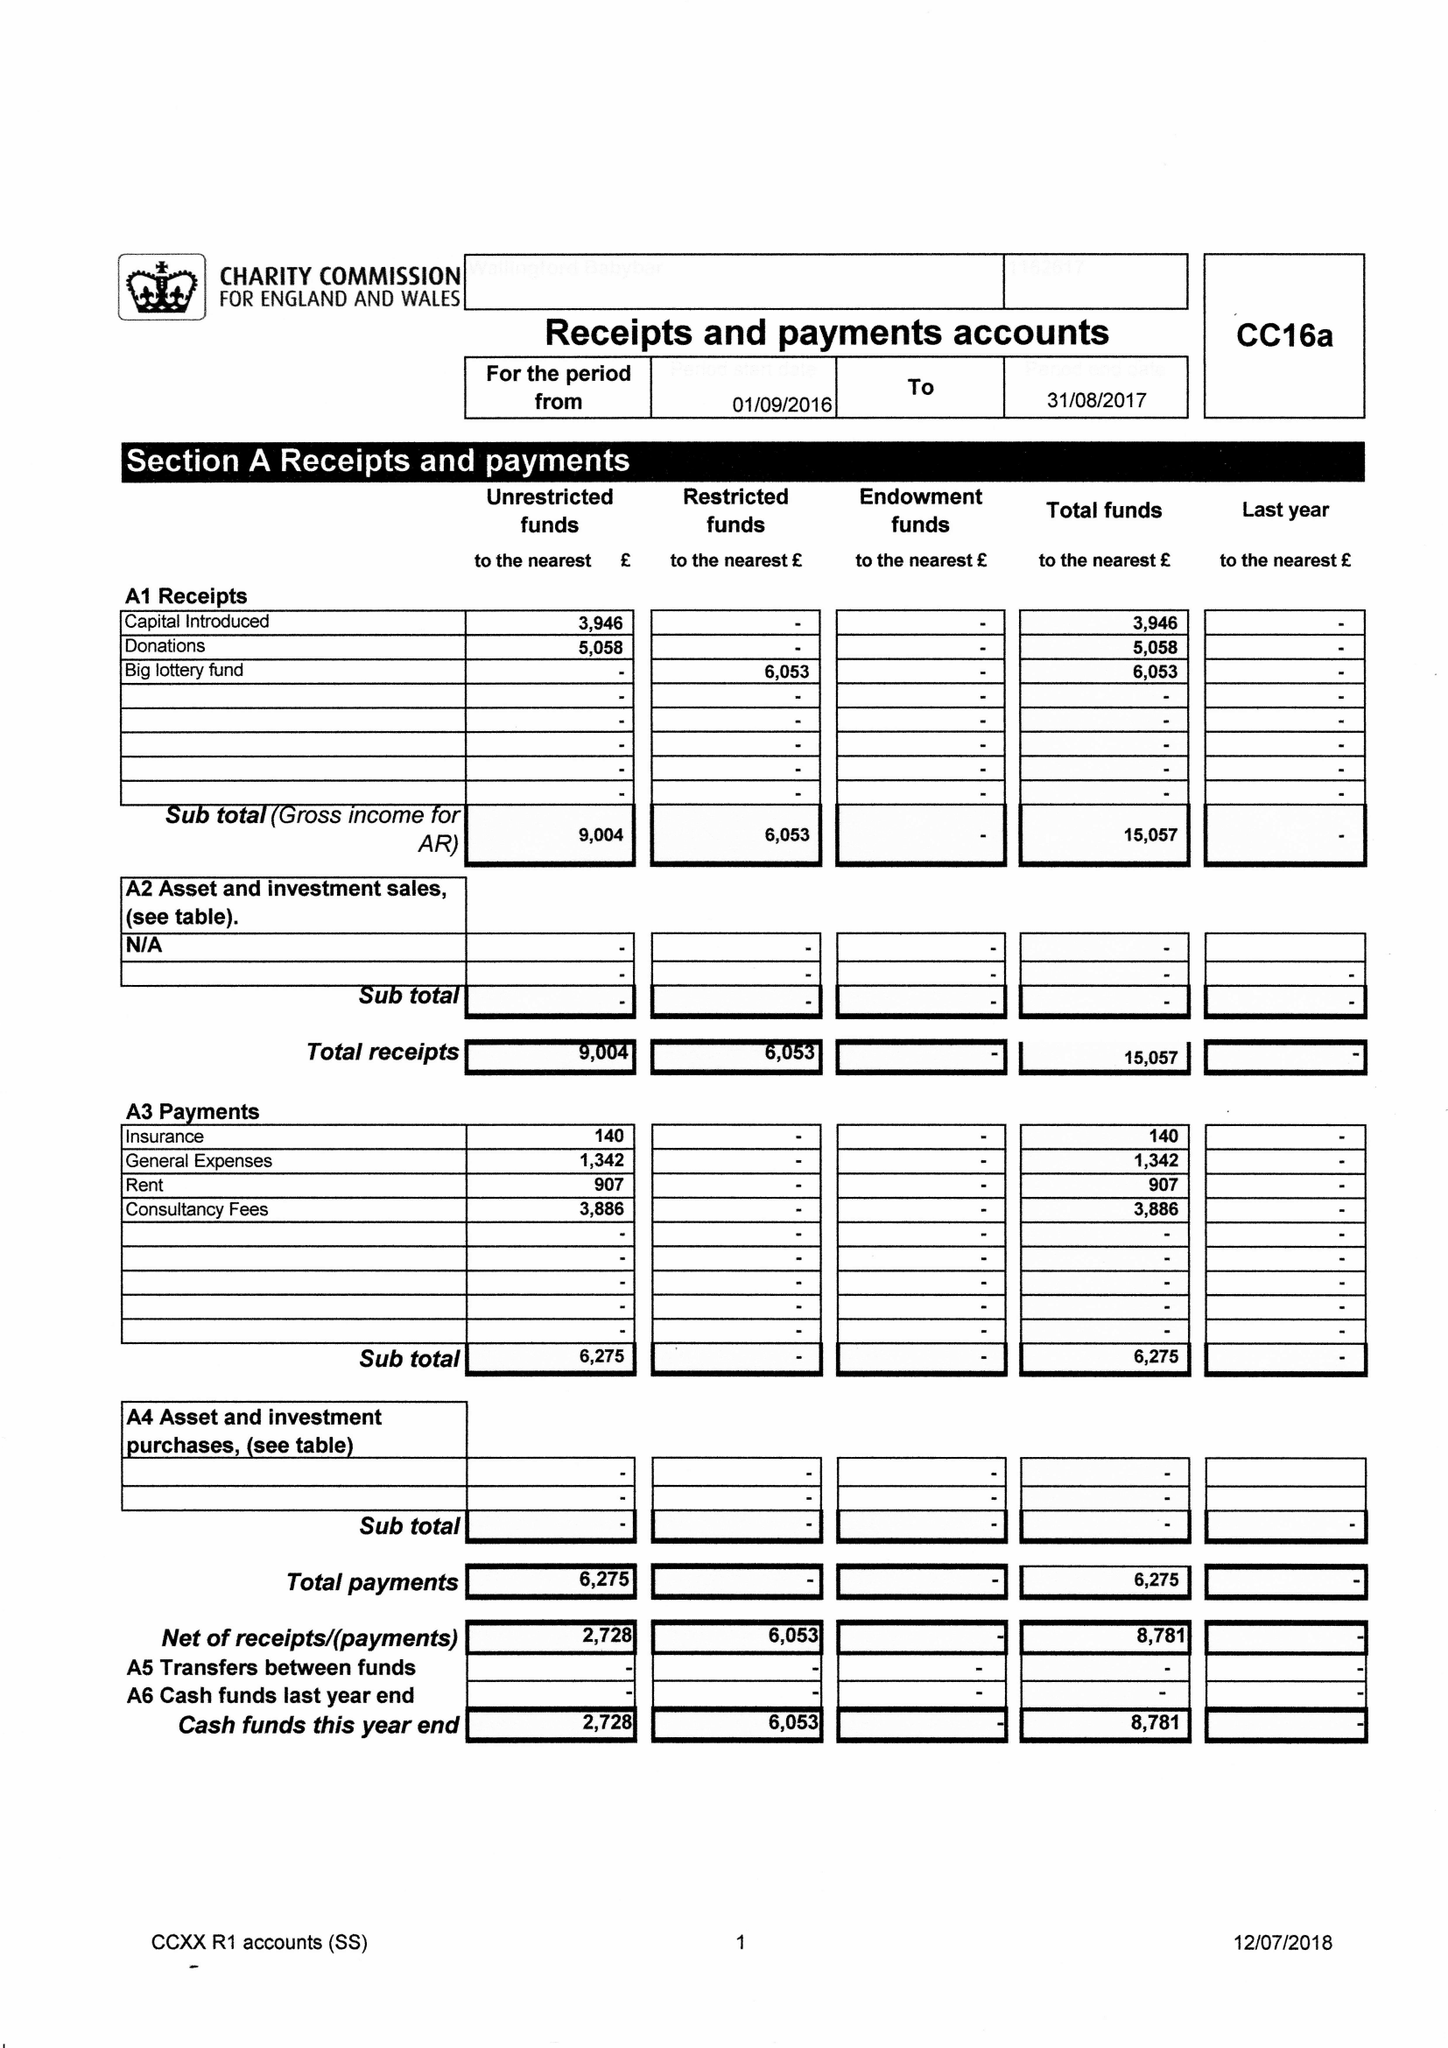What is the value for the address__street_line?
Answer the question using a single word or phrase. 41 SOVEREIGN PLACE 